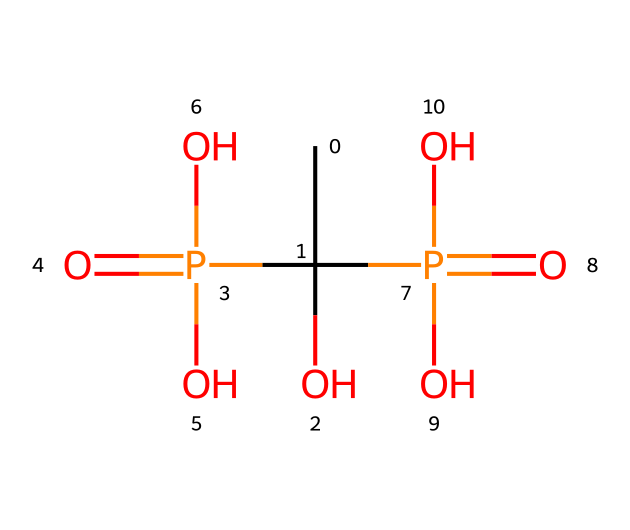What is the primary functional group in this compound? The chemical structure contains a phosphate group characterized by the presence of phosphorus central to four oxygen atoms. Among these, one of the phosphate groups is highlighted as being part of the bisphosphonate structure.
Answer: phosphate How many phosphorus atoms are present in this compound? By analyzing the SMILES representation, we can count the number of phosphorus (P) atoms. The structure includes two phosphorus atoms connected by an oxygen bridge, both contributing to the bisphosphonate architecture.
Answer: two What type of chemical reaction would you expect this compound to participate in due to its phosphate groups? Compounds with phosphate groups often engage in esterification or nucleophilic substitution reactions, as the phosphate moiety can donate its oxygen atoms for bonding with other molecules or ions.
Answer: nucleophilic substitution What is the oxidation state of phosphorus in this compound? In the given compound, phosphorus typically exhibits an oxidation state of +5 due to being bonded to oxygen in a tetrahedral arrangement, which is characteristic for phosphate groups.
Answer: +5 Which type of bond predominantly links the phosphorus to the oxygen in this structure? The phosphorus-oxygen bonds in phosphate compounds are primarily covalent, where electrons are shared between the atoms forming stable connections that are characteristic of phosphates and bisphosphonates.
Answer: covalent How many hydroxyl groups are present in this compound? Inspecting the chemical structure reveals that there are two hydroxyl (–OH) groups attached, which contribute to the reactivity and solubility of the bisphosphonate compound in biological systems.
Answer: two 